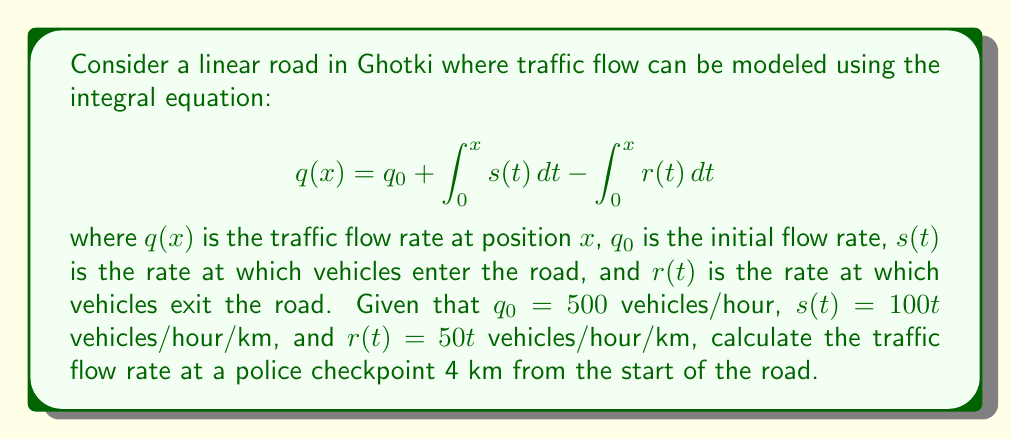Can you solve this math problem? To solve this problem, we'll follow these steps:

1) We're given the integral equation:
   $$q(x) = q_0 + \int_0^x s(t) dt - \int_0^x r(t) dt$$

2) We know:
   - $q_0 = 500$ vehicles/hour
   - $s(t) = 100t$ vehicles/hour/km
   - $r(t) = 50t$ vehicles/hour/km
   - We need to find $q(4)$

3) Let's evaluate the integrals:

   $$\int_0^x s(t) dt = \int_0^x 100t dt = 100 \cdot \frac{t^2}{2} \bigg|_0^x = 50x^2$$

   $$\int_0^x r(t) dt = \int_0^x 50t dt = 50 \cdot \frac{t^2}{2} \bigg|_0^x = 25x^2$$

4) Now we can rewrite our equation:

   $$q(x) = 500 + 50x^2 - 25x^2 = 500 + 25x^2$$

5) To find the traffic flow rate at 4 km, we substitute $x = 4$:

   $$q(4) = 500 + 25(4^2) = 500 + 25(16) = 500 + 400 = 900$$

Therefore, the traffic flow rate at the police checkpoint 4 km from the start of the road is 900 vehicles/hour.
Answer: 900 vehicles/hour 